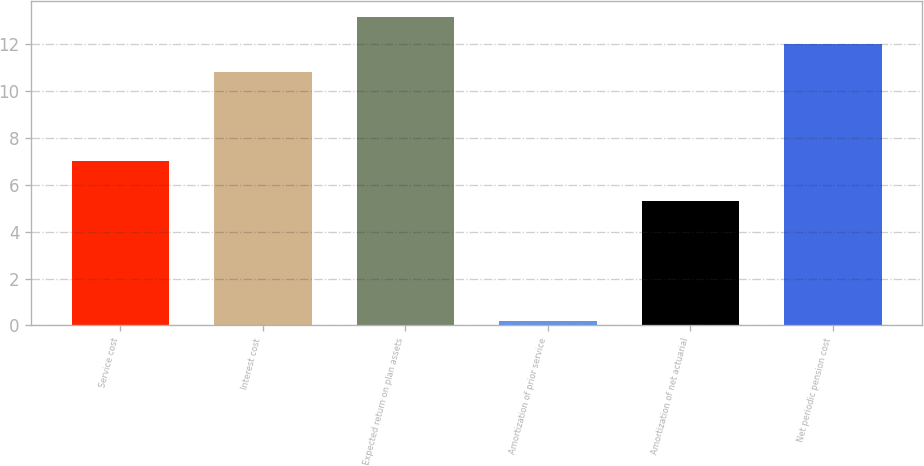<chart> <loc_0><loc_0><loc_500><loc_500><bar_chart><fcel>Service cost<fcel>Interest cost<fcel>Expected return on plan assets<fcel>Amortization of prior service<fcel>Amortization of net actuarial<fcel>Net periodic pension cost<nl><fcel>7<fcel>10.8<fcel>13.16<fcel>0.2<fcel>5.3<fcel>11.98<nl></chart> 